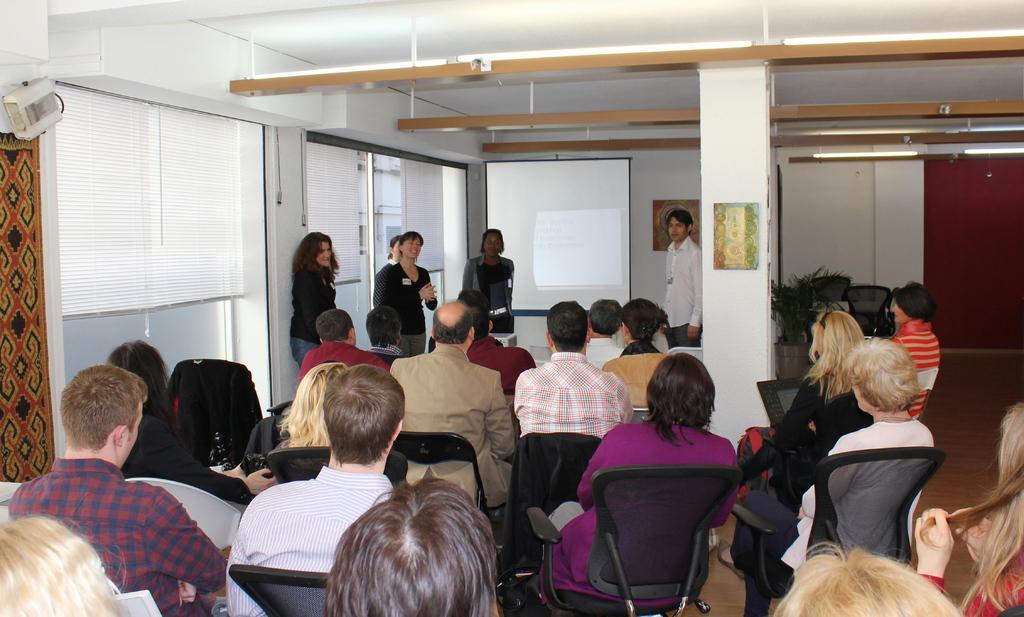How would you summarize this image in a sentence or two? In this image there are a few people sitting on the chairs and there are a few people standing on the floor. There are photo frames on the wall. In the background of the image there are flower pots. There is a screen. On the left side of the image there are glass doors. On top of the image there are lights. 